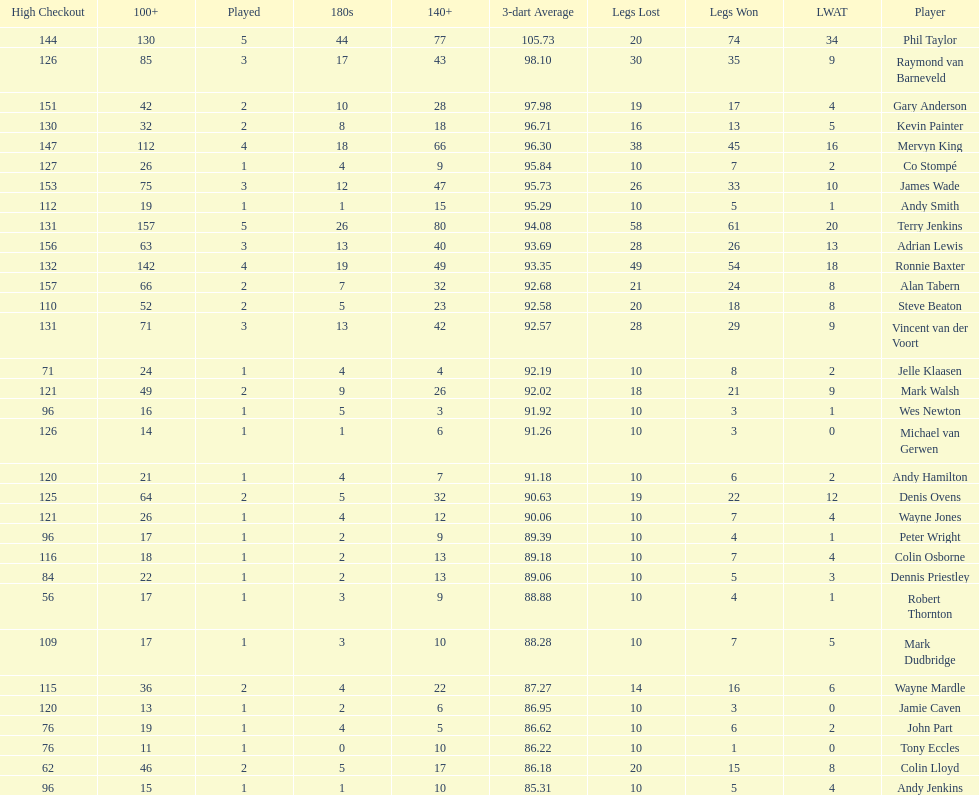Which player has his high checkout as 116? Colin Osborne. 